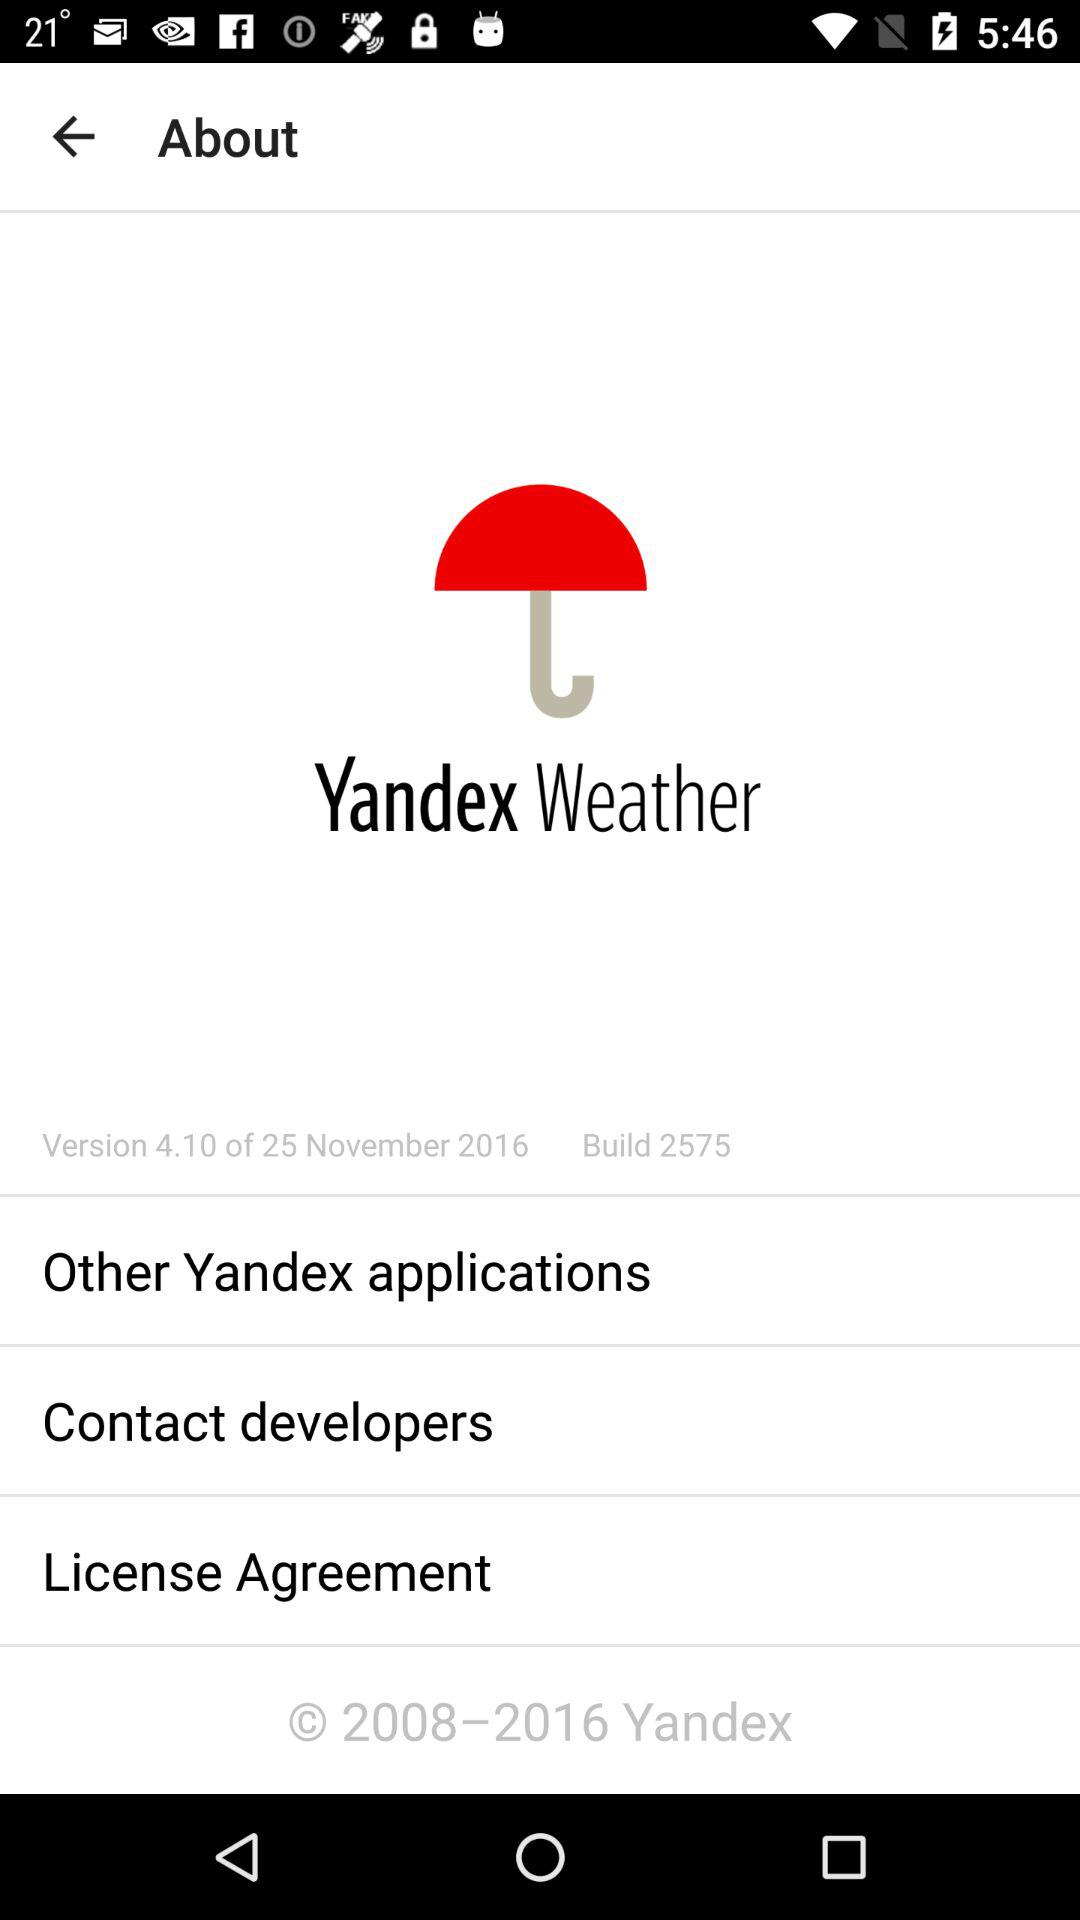Which version is given? The given version is 4.10. 